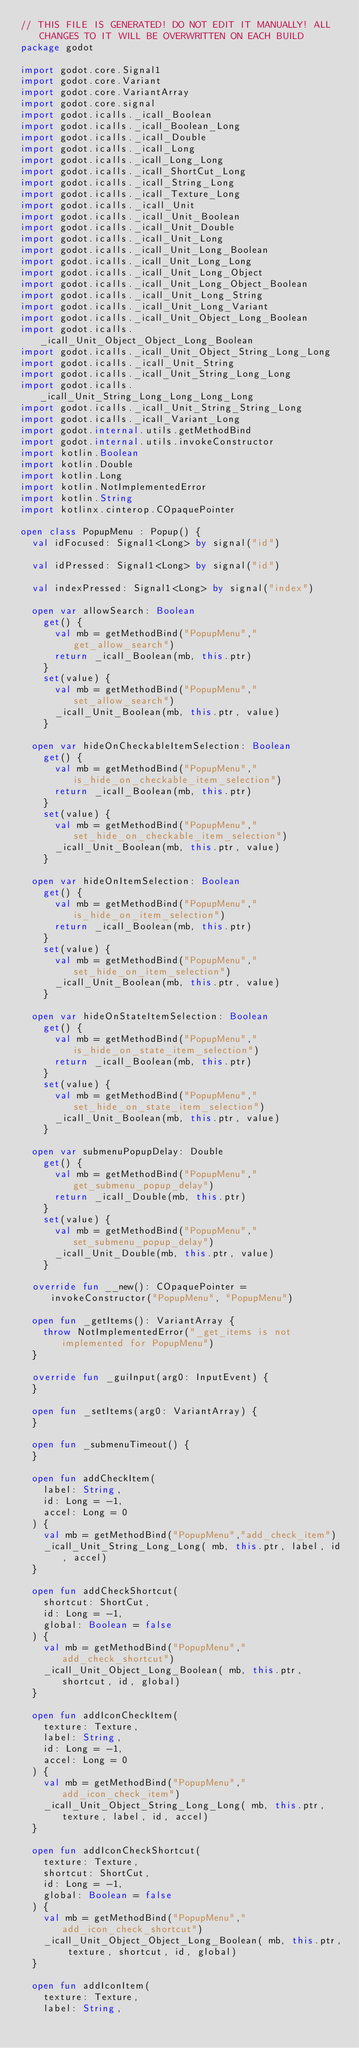Convert code to text. <code><loc_0><loc_0><loc_500><loc_500><_Kotlin_>// THIS FILE IS GENERATED! DO NOT EDIT IT MANUALLY! ALL CHANGES TO IT WILL BE OVERWRITTEN ON EACH BUILD
package godot

import godot.core.Signal1
import godot.core.Variant
import godot.core.VariantArray
import godot.core.signal
import godot.icalls._icall_Boolean
import godot.icalls._icall_Boolean_Long
import godot.icalls._icall_Double
import godot.icalls._icall_Long
import godot.icalls._icall_Long_Long
import godot.icalls._icall_ShortCut_Long
import godot.icalls._icall_String_Long
import godot.icalls._icall_Texture_Long
import godot.icalls._icall_Unit
import godot.icalls._icall_Unit_Boolean
import godot.icalls._icall_Unit_Double
import godot.icalls._icall_Unit_Long
import godot.icalls._icall_Unit_Long_Boolean
import godot.icalls._icall_Unit_Long_Long
import godot.icalls._icall_Unit_Long_Object
import godot.icalls._icall_Unit_Long_Object_Boolean
import godot.icalls._icall_Unit_Long_String
import godot.icalls._icall_Unit_Long_Variant
import godot.icalls._icall_Unit_Object_Long_Boolean
import godot.icalls._icall_Unit_Object_Object_Long_Boolean
import godot.icalls._icall_Unit_Object_String_Long_Long
import godot.icalls._icall_Unit_String
import godot.icalls._icall_Unit_String_Long_Long
import godot.icalls._icall_Unit_String_Long_Long_Long_Long
import godot.icalls._icall_Unit_String_String_Long
import godot.icalls._icall_Variant_Long
import godot.internal.utils.getMethodBind
import godot.internal.utils.invokeConstructor
import kotlin.Boolean
import kotlin.Double
import kotlin.Long
import kotlin.NotImplementedError
import kotlin.String
import kotlinx.cinterop.COpaquePointer

open class PopupMenu : Popup() {
  val idFocused: Signal1<Long> by signal("id")

  val idPressed: Signal1<Long> by signal("id")

  val indexPressed: Signal1<Long> by signal("index")

  open var allowSearch: Boolean
    get() {
      val mb = getMethodBind("PopupMenu","get_allow_search")
      return _icall_Boolean(mb, this.ptr)
    }
    set(value) {
      val mb = getMethodBind("PopupMenu","set_allow_search")
      _icall_Unit_Boolean(mb, this.ptr, value)
    }

  open var hideOnCheckableItemSelection: Boolean
    get() {
      val mb = getMethodBind("PopupMenu","is_hide_on_checkable_item_selection")
      return _icall_Boolean(mb, this.ptr)
    }
    set(value) {
      val mb = getMethodBind("PopupMenu","set_hide_on_checkable_item_selection")
      _icall_Unit_Boolean(mb, this.ptr, value)
    }

  open var hideOnItemSelection: Boolean
    get() {
      val mb = getMethodBind("PopupMenu","is_hide_on_item_selection")
      return _icall_Boolean(mb, this.ptr)
    }
    set(value) {
      val mb = getMethodBind("PopupMenu","set_hide_on_item_selection")
      _icall_Unit_Boolean(mb, this.ptr, value)
    }

  open var hideOnStateItemSelection: Boolean
    get() {
      val mb = getMethodBind("PopupMenu","is_hide_on_state_item_selection")
      return _icall_Boolean(mb, this.ptr)
    }
    set(value) {
      val mb = getMethodBind("PopupMenu","set_hide_on_state_item_selection")
      _icall_Unit_Boolean(mb, this.ptr, value)
    }

  open var submenuPopupDelay: Double
    get() {
      val mb = getMethodBind("PopupMenu","get_submenu_popup_delay")
      return _icall_Double(mb, this.ptr)
    }
    set(value) {
      val mb = getMethodBind("PopupMenu","set_submenu_popup_delay")
      _icall_Unit_Double(mb, this.ptr, value)
    }

  override fun __new(): COpaquePointer = invokeConstructor("PopupMenu", "PopupMenu")

  open fun _getItems(): VariantArray {
    throw NotImplementedError("_get_items is not implemented for PopupMenu")
  }

  override fun _guiInput(arg0: InputEvent) {
  }

  open fun _setItems(arg0: VariantArray) {
  }

  open fun _submenuTimeout() {
  }

  open fun addCheckItem(
    label: String,
    id: Long = -1,
    accel: Long = 0
  ) {
    val mb = getMethodBind("PopupMenu","add_check_item")
    _icall_Unit_String_Long_Long( mb, this.ptr, label, id, accel)
  }

  open fun addCheckShortcut(
    shortcut: ShortCut,
    id: Long = -1,
    global: Boolean = false
  ) {
    val mb = getMethodBind("PopupMenu","add_check_shortcut")
    _icall_Unit_Object_Long_Boolean( mb, this.ptr, shortcut, id, global)
  }

  open fun addIconCheckItem(
    texture: Texture,
    label: String,
    id: Long = -1,
    accel: Long = 0
  ) {
    val mb = getMethodBind("PopupMenu","add_icon_check_item")
    _icall_Unit_Object_String_Long_Long( mb, this.ptr, texture, label, id, accel)
  }

  open fun addIconCheckShortcut(
    texture: Texture,
    shortcut: ShortCut,
    id: Long = -1,
    global: Boolean = false
  ) {
    val mb = getMethodBind("PopupMenu","add_icon_check_shortcut")
    _icall_Unit_Object_Object_Long_Boolean( mb, this.ptr, texture, shortcut, id, global)
  }

  open fun addIconItem(
    texture: Texture,
    label: String,</code> 